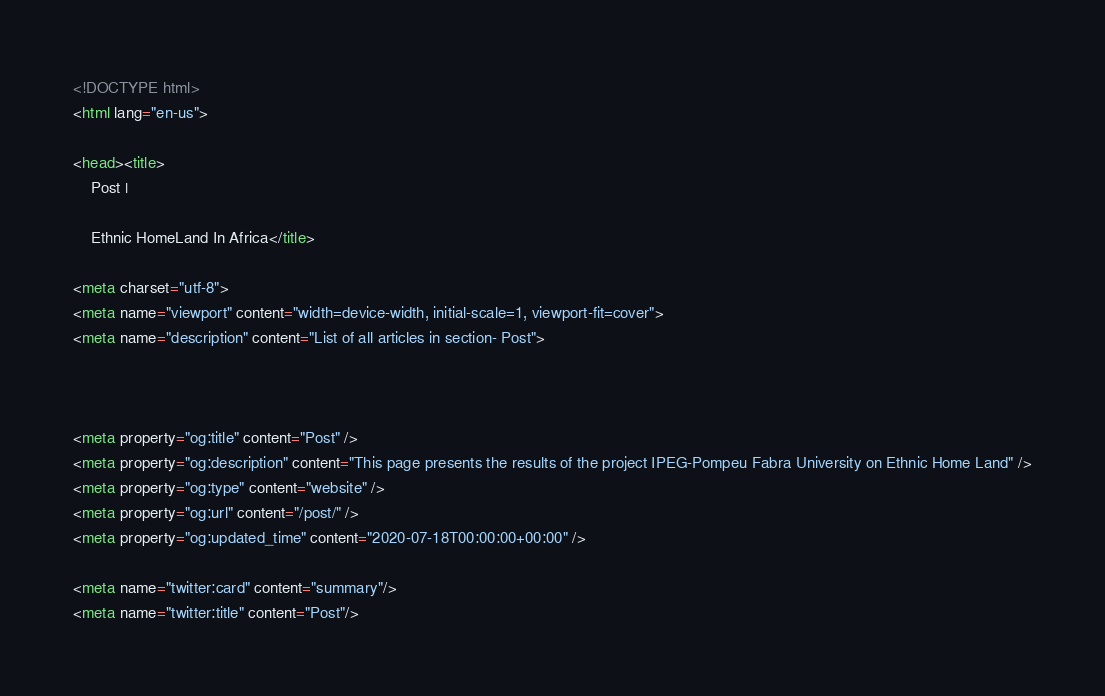<code> <loc_0><loc_0><loc_500><loc_500><_HTML_><!DOCTYPE html>
<html lang="en-us">

<head><title>
    Post | 
    
    Ethnic HomeLand In Africa</title>

<meta charset="utf-8">
<meta name="viewport" content="width=device-width, initial-scale=1, viewport-fit=cover">
<meta name="description" content="List of all articles in section- Post">



<meta property="og:title" content="Post" />
<meta property="og:description" content="This page presents the results of the project IPEG-Pompeu Fabra University on Ethnic Home Land" />
<meta property="og:type" content="website" />
<meta property="og:url" content="/post/" />
<meta property="og:updated_time" content="2020-07-18T00:00:00+00:00" />

<meta name="twitter:card" content="summary"/>
<meta name="twitter:title" content="Post"/></code> 